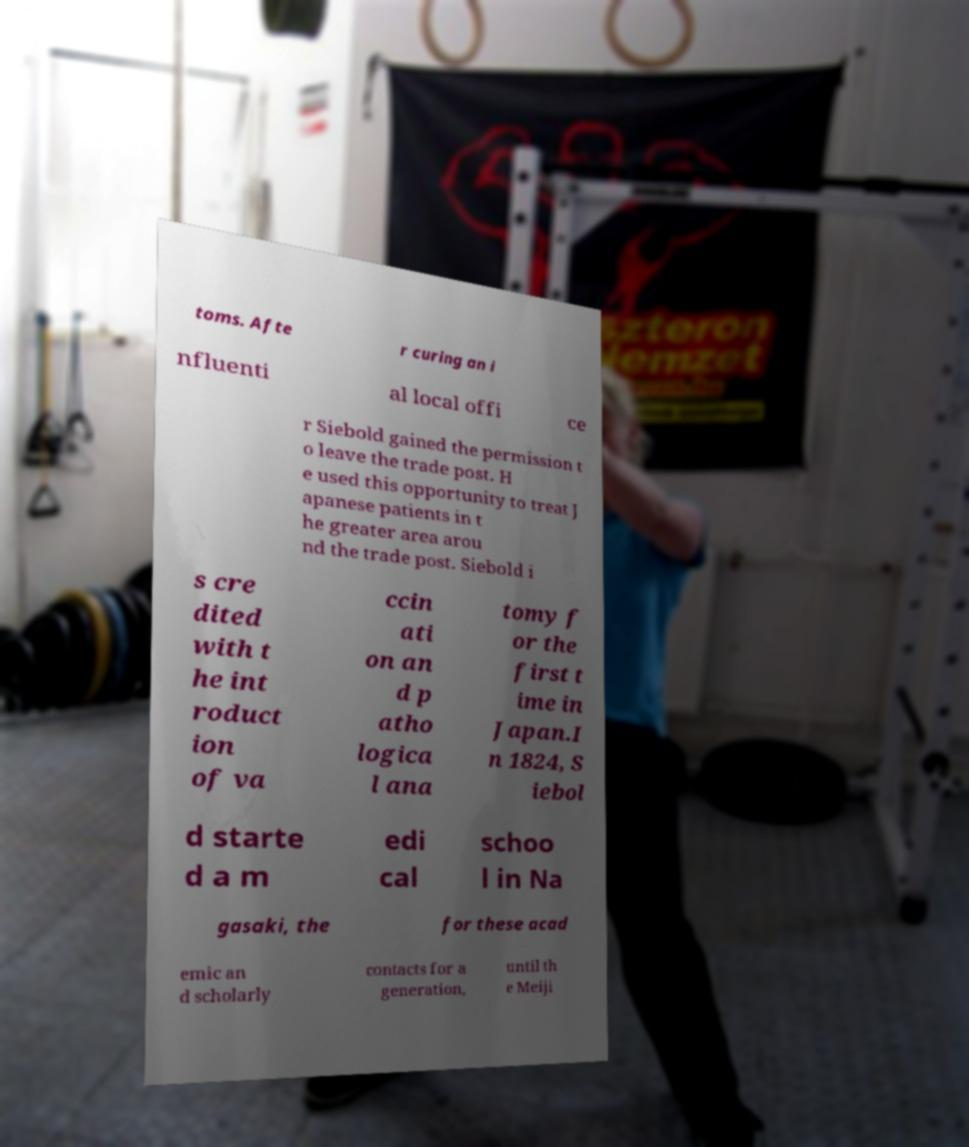For documentation purposes, I need the text within this image transcribed. Could you provide that? toms. Afte r curing an i nfluenti al local offi ce r Siebold gained the permission t o leave the trade post. H e used this opportunity to treat J apanese patients in t he greater area arou nd the trade post. Siebold i s cre dited with t he int roduct ion of va ccin ati on an d p atho logica l ana tomy f or the first t ime in Japan.I n 1824, S iebol d starte d a m edi cal schoo l in Na gasaki, the for these acad emic an d scholarly contacts for a generation, until th e Meiji 